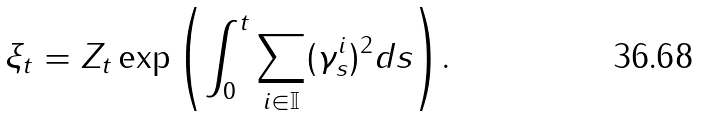<formula> <loc_0><loc_0><loc_500><loc_500>\xi _ { t } = Z _ { t } \exp { \left ( \int _ { 0 } ^ { t } \sum _ { i \in \mathbb { I } } ( \gamma ^ { i } _ { s } ) ^ { 2 } d s \right ) } .</formula> 